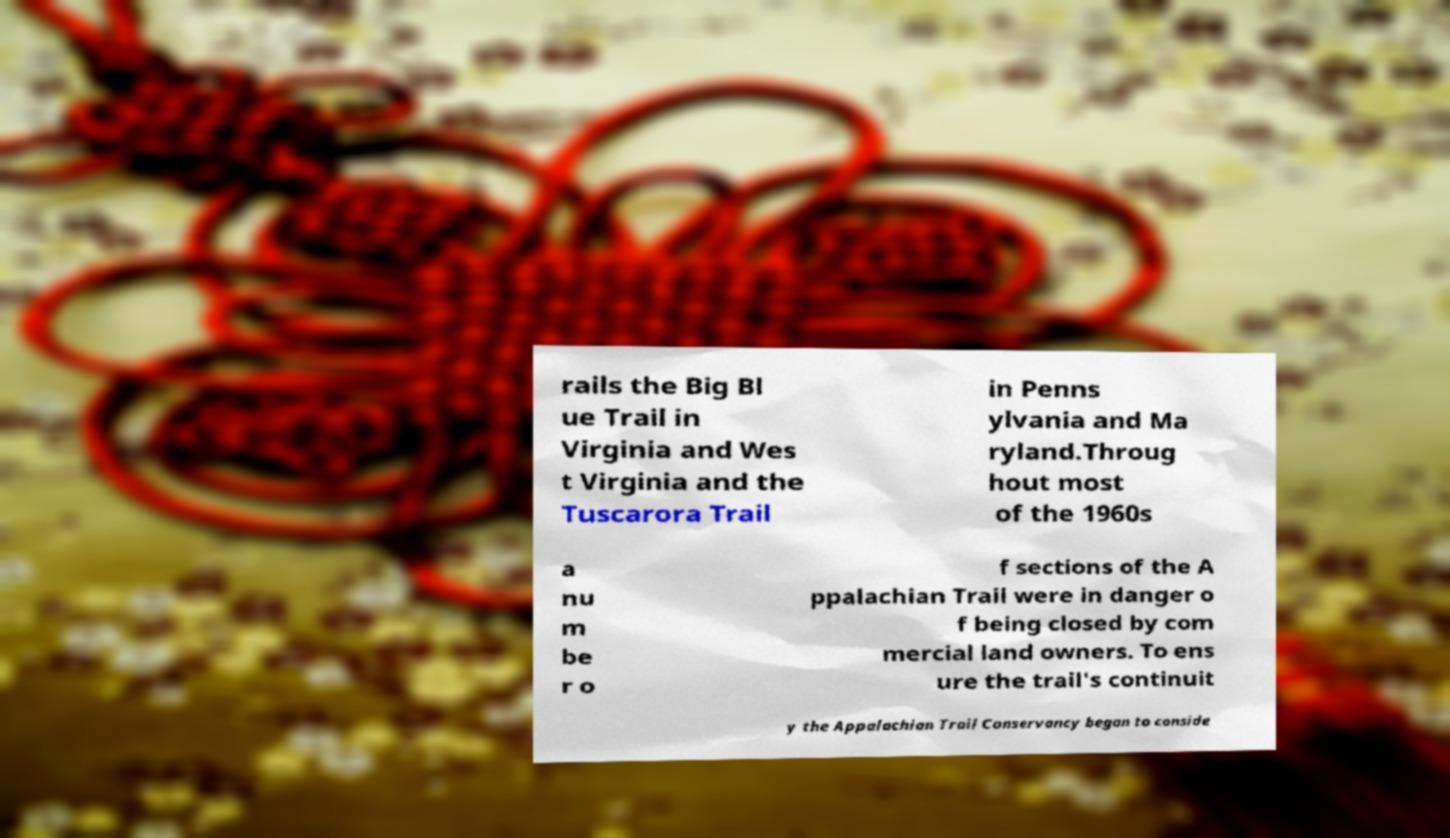Could you extract and type out the text from this image? rails the Big Bl ue Trail in Virginia and Wes t Virginia and the Tuscarora Trail in Penns ylvania and Ma ryland.Throug hout most of the 1960s a nu m be r o f sections of the A ppalachian Trail were in danger o f being closed by com mercial land owners. To ens ure the trail's continuit y the Appalachian Trail Conservancy began to conside 